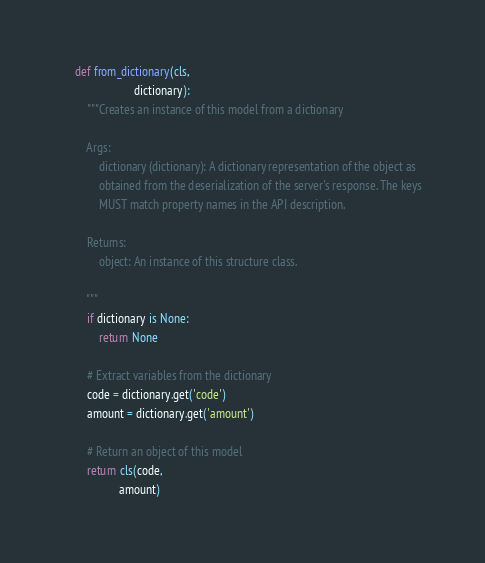Convert code to text. <code><loc_0><loc_0><loc_500><loc_500><_Python_>    def from_dictionary(cls,
                        dictionary):
        """Creates an instance of this model from a dictionary

        Args:
            dictionary (dictionary): A dictionary representation of the object as
            obtained from the deserialization of the server's response. The keys
            MUST match property names in the API description.

        Returns:
            object: An instance of this structure class.

        """
        if dictionary is None:
            return None

        # Extract variables from the dictionary
        code = dictionary.get('code')
        amount = dictionary.get('amount')

        # Return an object of this model
        return cls(code,
                   amount)


</code> 